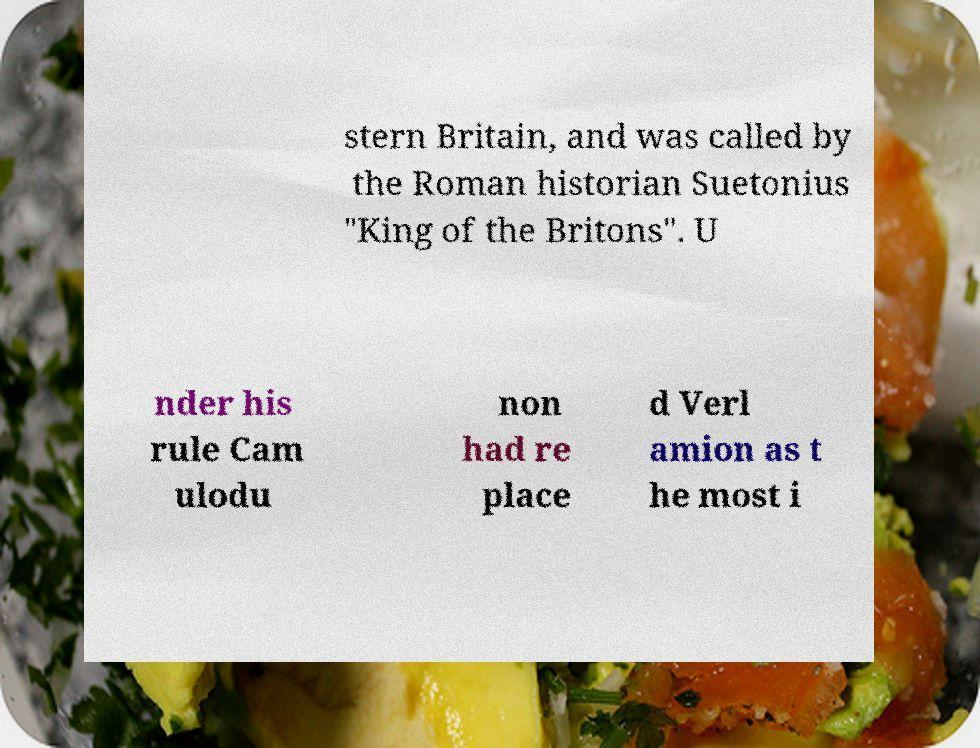Please read and relay the text visible in this image. What does it say? stern Britain, and was called by the Roman historian Suetonius "King of the Britons". U nder his rule Cam ulodu non had re place d Verl amion as t he most i 